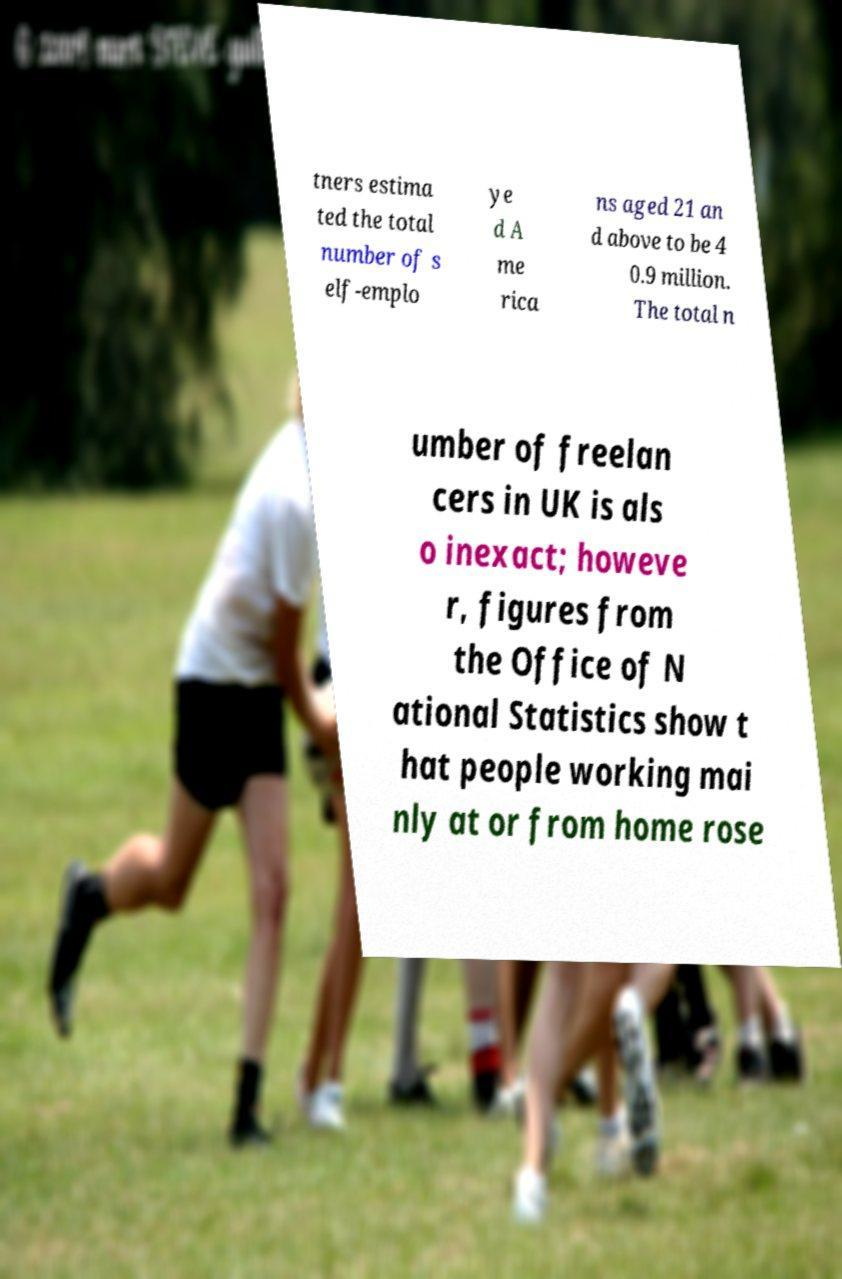Can you read and provide the text displayed in the image?This photo seems to have some interesting text. Can you extract and type it out for me? tners estima ted the total number of s elf-emplo ye d A me rica ns aged 21 an d above to be 4 0.9 million. The total n umber of freelan cers in UK is als o inexact; howeve r, figures from the Office of N ational Statistics show t hat people working mai nly at or from home rose 